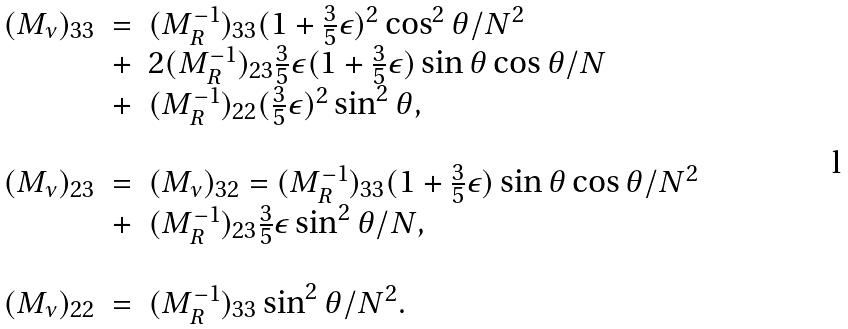<formula> <loc_0><loc_0><loc_500><loc_500>\begin{array} { c c l } ( M _ { \nu } ) _ { 3 3 } & = & ( M _ { R } ^ { - 1 } ) _ { 3 3 } ( 1 + \frac { 3 } { 5 } \epsilon ) ^ { 2 } \cos ^ { 2 } \theta / N ^ { 2 } \\ & + & 2 ( M _ { R } ^ { - 1 } ) _ { 2 3 } \frac { 3 } { 5 } \epsilon ( 1 + \frac { 3 } { 5 } \epsilon ) \sin \theta \cos \theta / N \\ & + & ( M _ { R } ^ { - 1 } ) _ { 2 2 } ( \frac { 3 } { 5 } \epsilon ) ^ { 2 } \sin ^ { 2 } \theta , \\ & & \\ ( M _ { \nu } ) _ { 2 3 } & = & ( M _ { \nu } ) _ { 3 2 } = ( M _ { R } ^ { - 1 } ) _ { 3 3 } ( 1 + \frac { 3 } { 5 } \epsilon ) \sin \theta \cos \theta / N ^ { 2 } \\ & + & ( M _ { R } ^ { - 1 } ) _ { 2 3 } \frac { 3 } { 5 } \epsilon \sin ^ { 2 } \theta / N , \\ & & \\ ( M _ { \nu } ) _ { 2 2 } & = & ( M _ { R } ^ { - 1 } ) _ { 3 3 } \sin ^ { 2 } \theta / N ^ { 2 } . \\ \end{array}</formula> 